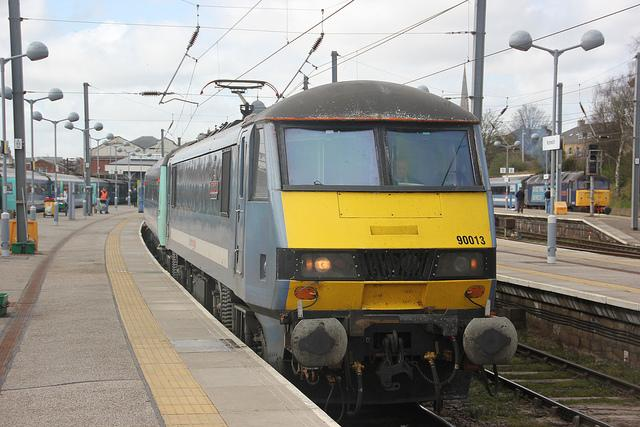For what group of people is the yellow area on the platform built? passengers 